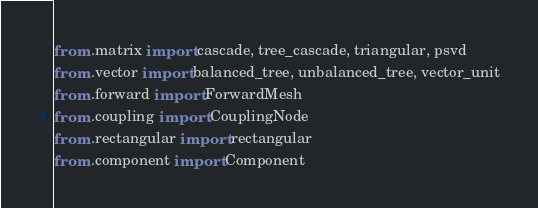<code> <loc_0><loc_0><loc_500><loc_500><_Python_>from .matrix import cascade, tree_cascade, triangular, psvd
from .vector import balanced_tree, unbalanced_tree, vector_unit
from .forward import ForwardMesh
from .coupling import CouplingNode
from .rectangular import rectangular
from .component import Component
</code> 